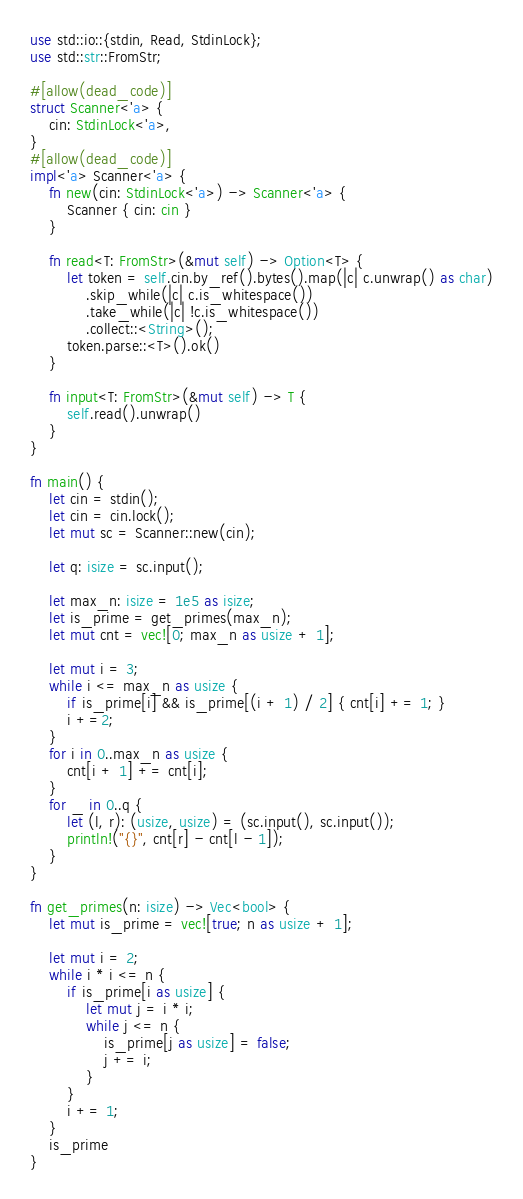<code> <loc_0><loc_0><loc_500><loc_500><_Rust_>use std::io::{stdin, Read, StdinLock};
use std::str::FromStr;

#[allow(dead_code)]
struct Scanner<'a> {
    cin: StdinLock<'a>,
}
#[allow(dead_code)]
impl<'a> Scanner<'a> {
    fn new(cin: StdinLock<'a>) -> Scanner<'a> {
        Scanner { cin: cin }
    }

    fn read<T: FromStr>(&mut self) -> Option<T> {
        let token = self.cin.by_ref().bytes().map(|c| c.unwrap() as char)
            .skip_while(|c| c.is_whitespace())
            .take_while(|c| !c.is_whitespace())
            .collect::<String>();
        token.parse::<T>().ok()
    }

    fn input<T: FromStr>(&mut self) -> T {
        self.read().unwrap()
    }
}

fn main() {
    let cin = stdin();
    let cin = cin.lock();
    let mut sc = Scanner::new(cin);

    let q: isize = sc.input();

    let max_n: isize = 1e5 as isize;
    let is_prime = get_primes(max_n);
    let mut cnt = vec![0; max_n as usize + 1];

    let mut i = 3;
    while i <= max_n as usize {
        if is_prime[i] && is_prime[(i + 1) / 2] { cnt[i] += 1; }
        i +=2;
    }
    for i in 0..max_n as usize {
        cnt[i + 1] += cnt[i];
    }
    for _ in 0..q {
        let (l, r): (usize, usize) = (sc.input(), sc.input());
        println!("{}", cnt[r] - cnt[l - 1]);
    }
}

fn get_primes(n: isize) -> Vec<bool> {
    let mut is_prime = vec![true; n as usize + 1];

    let mut i = 2;
    while i * i <= n {
        if is_prime[i as usize] {
            let mut j = i * i;
            while j <= n {
                is_prime[j as usize] = false;
                j += i;
            }
        }
        i += 1;
    }
    is_prime
}
</code> 